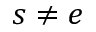Convert formula to latex. <formula><loc_0><loc_0><loc_500><loc_500>s \neq e</formula> 